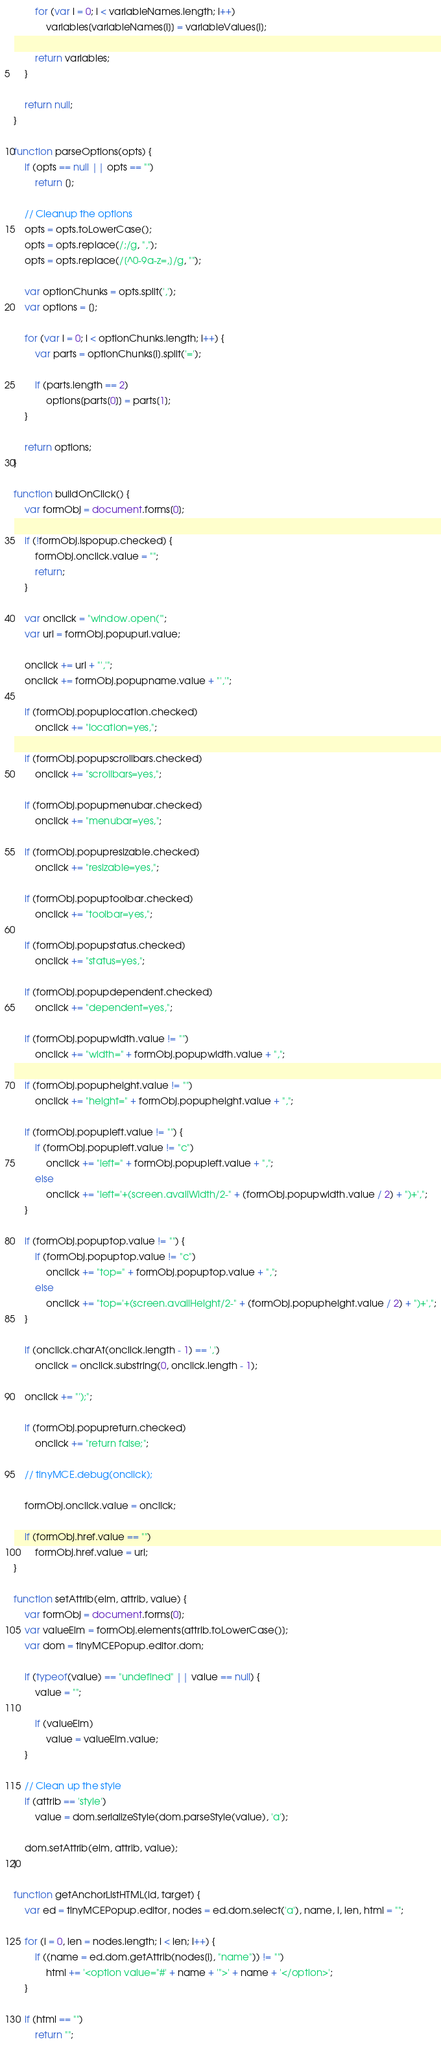Convert code to text. <code><loc_0><loc_0><loc_500><loc_500><_JavaScript_>        for (var i = 0; i < variableNames.length; i++)
            variables[variableNames[i]] = variableValues[i];

        return variables;
    }

    return null;
}

function parseOptions(opts) {
    if (opts == null || opts == "")
        return [];

    // Cleanup the options
    opts = opts.toLowerCase();
    opts = opts.replace(/;/g, ",");
    opts = opts.replace(/[^0-9a-z=,]/g, "");

    var optionChunks = opts.split(',');
    var options = [];

    for (var i = 0; i < optionChunks.length; i++) {
        var parts = optionChunks[i].split('=');

        if (parts.length == 2)
            options[parts[0]] = parts[1];
    }

    return options;
}

function buildOnClick() {
    var formObj = document.forms[0];

    if (!formObj.ispopup.checked) {
        formObj.onclick.value = "";
        return;
    }

    var onclick = "window.open('";
    var url = formObj.popupurl.value;

    onclick += url + "','";
    onclick += formObj.popupname.value + "','";

    if (formObj.popuplocation.checked)
        onclick += "location=yes,";

    if (formObj.popupscrollbars.checked)
        onclick += "scrollbars=yes,";

    if (formObj.popupmenubar.checked)
        onclick += "menubar=yes,";

    if (formObj.popupresizable.checked)
        onclick += "resizable=yes,";

    if (formObj.popuptoolbar.checked)
        onclick += "toolbar=yes,";

    if (formObj.popupstatus.checked)
        onclick += "status=yes,";

    if (formObj.popupdependent.checked)
        onclick += "dependent=yes,";

    if (formObj.popupwidth.value != "")
        onclick += "width=" + formObj.popupwidth.value + ",";

    if (formObj.popupheight.value != "")
        onclick += "height=" + formObj.popupheight.value + ",";

    if (formObj.popupleft.value != "") {
        if (formObj.popupleft.value != "c")
            onclick += "left=" + formObj.popupleft.value + ",";
        else
            onclick += "left='+(screen.availWidth/2-" + (formObj.popupwidth.value / 2) + ")+',";
    }

    if (formObj.popuptop.value != "") {
        if (formObj.popuptop.value != "c")
            onclick += "top=" + formObj.popuptop.value + ",";
        else
            onclick += "top='+(screen.availHeight/2-" + (formObj.popupheight.value / 2) + ")+',";
    }

    if (onclick.charAt(onclick.length - 1) == ',')
        onclick = onclick.substring(0, onclick.length - 1);

    onclick += "');";

    if (formObj.popupreturn.checked)
        onclick += "return false;";

    // tinyMCE.debug(onclick);

    formObj.onclick.value = onclick;

    if (formObj.href.value == "")
        formObj.href.value = url;
}

function setAttrib(elm, attrib, value) {
    var formObj = document.forms[0];
    var valueElm = formObj.elements[attrib.toLowerCase()];
    var dom = tinyMCEPopup.editor.dom;

    if (typeof(value) == "undefined" || value == null) {
        value = "";

        if (valueElm)
            value = valueElm.value;
    }

    // Clean up the style
    if (attrib == 'style')
        value = dom.serializeStyle(dom.parseStyle(value), 'a');

    dom.setAttrib(elm, attrib, value);
}

function getAnchorListHTML(id, target) {
    var ed = tinyMCEPopup.editor, nodes = ed.dom.select('a'), name, i, len, html = "";

    for (i = 0, len = nodes.length; i < len; i++) {
        if ((name = ed.dom.getAttrib(nodes[i], "name")) != "")
            html += '<option value="#' + name + '">' + name + '</option>';
    }

    if (html == "")
        return "";
</code> 